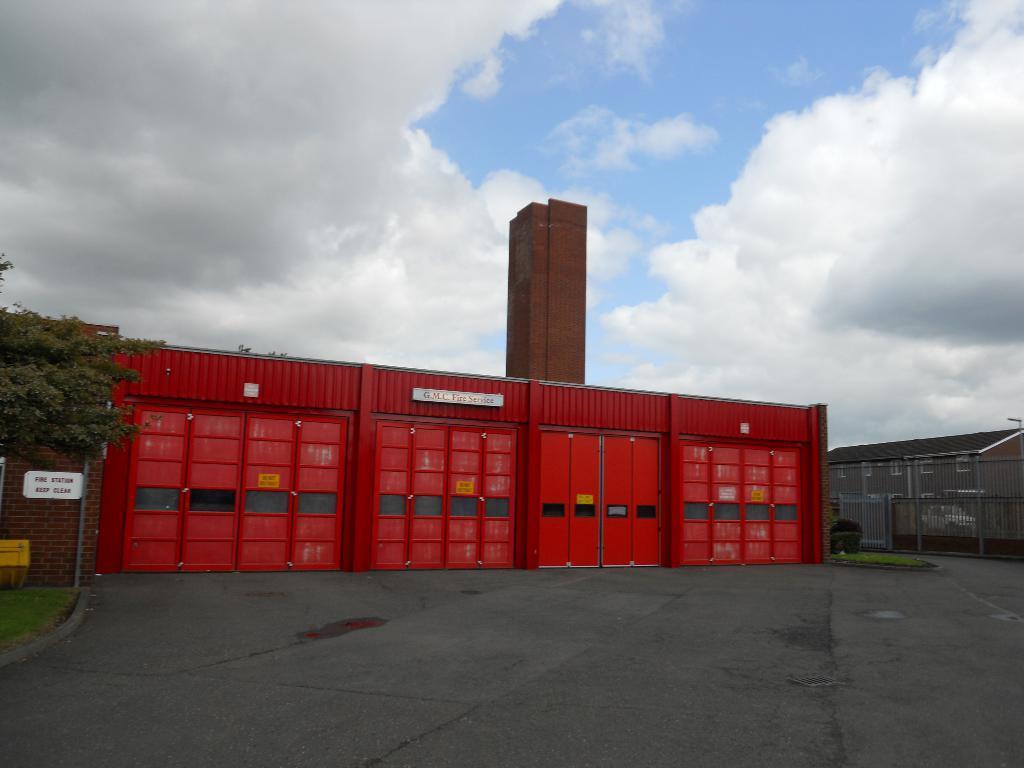How would you summarize this image in a sentence or two? In this image there is big go-down in front of that there is a road and tree, also there are some clouds in the sky. 